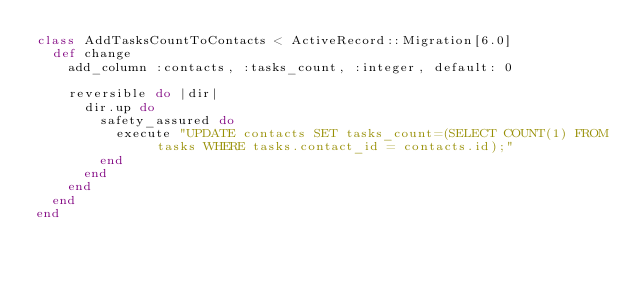Convert code to text. <code><loc_0><loc_0><loc_500><loc_500><_Ruby_>class AddTasksCountToContacts < ActiveRecord::Migration[6.0]
  def change
    add_column :contacts, :tasks_count, :integer, default: 0

    reversible do |dir|
      dir.up do
        safety_assured do
          execute "UPDATE contacts SET tasks_count=(SELECT COUNT(1) FROM tasks WHERE tasks.contact_id = contacts.id);"
        end
      end
    end
  end
end
</code> 